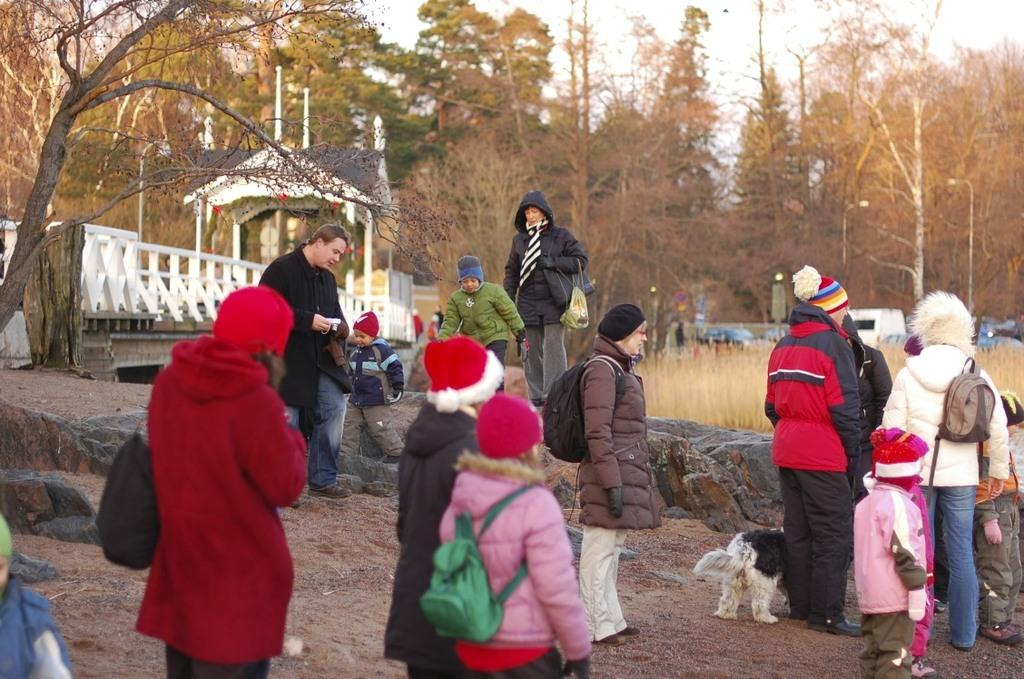What are the people in the image wearing? The people in the image are wearing coats. What type of animal is present in the image? There is a dog in the image. Where is the dog located in the image? The dog is at the bottom of the image. What can be seen in the background of the image? There are trees and a bridge in the background of the image. What type of toothbrush is the dog using in the image? There is no toothbrush present in the image, and the dog is not using any object in the image. 